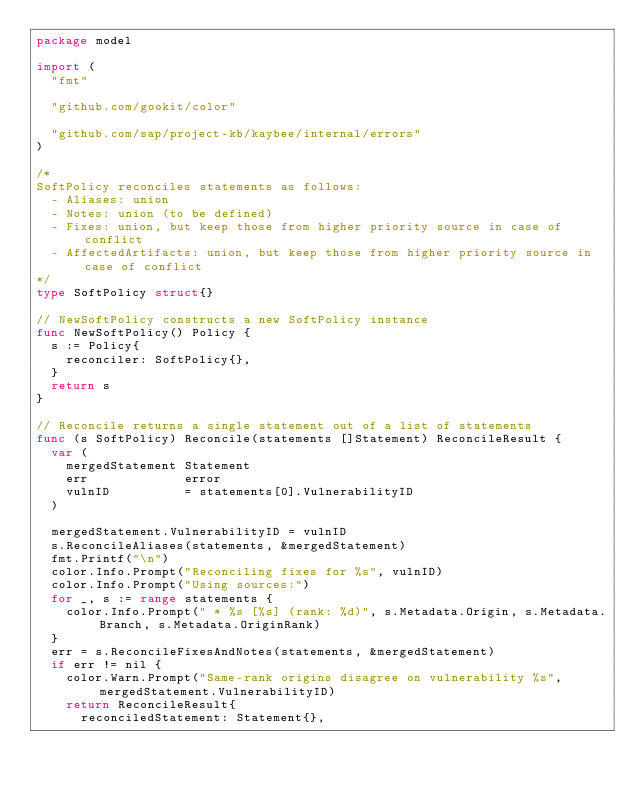<code> <loc_0><loc_0><loc_500><loc_500><_Go_>package model

import (
	"fmt"

	"github.com/gookit/color"

	"github.com/sap/project-kb/kaybee/internal/errors"
)

/*
SoftPolicy reconciles statements as follows:
  - Aliases: union
  - Notes: union (to be defined)
  - Fixes: union, but keep those from higher priority source in case of conflict
  - AffectedArtifacts: union, but keep those from higher priority source in case of conflict
*/
type SoftPolicy struct{}

// NewSoftPolicy constructs a new SoftPolicy instance
func NewSoftPolicy() Policy {
	s := Policy{
		reconciler: SoftPolicy{},
	}
	return s
}

// Reconcile returns a single statement out of a list of statements
func (s SoftPolicy) Reconcile(statements []Statement) ReconcileResult {
	var (
		mergedStatement Statement
		err             error
		vulnID          = statements[0].VulnerabilityID
	)

	mergedStatement.VulnerabilityID = vulnID
	s.ReconcileAliases(statements, &mergedStatement)
	fmt.Printf("\n")
	color.Info.Prompt("Reconciling fixes for %s", vulnID)
	color.Info.Prompt("Using sources:")
	for _, s := range statements {
		color.Info.Prompt(" * %s [%s] (rank: %d)", s.Metadata.Origin, s.Metadata.Branch, s.Metadata.OriginRank)
	}
	err = s.ReconcileFixesAndNotes(statements, &mergedStatement)
	if err != nil {
		color.Warn.Prompt("Same-rank origins disagree on vulnerability %s", mergedStatement.VulnerabilityID)
		return ReconcileResult{
			reconciledStatement: Statement{},</code> 